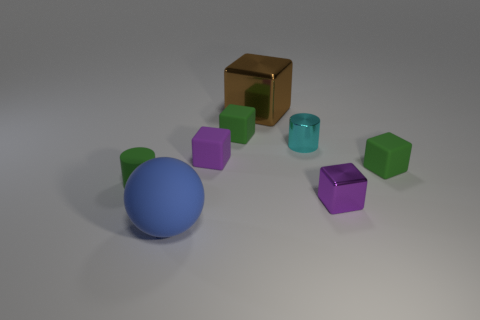Subtract 2 cubes. How many cubes are left? 3 Subtract all red blocks. Subtract all blue balls. How many blocks are left? 5 Add 1 large blue cubes. How many objects exist? 9 Subtract all spheres. How many objects are left? 7 Add 8 small green cylinders. How many small green cylinders are left? 9 Add 5 small purple rubber cylinders. How many small purple rubber cylinders exist? 5 Subtract 0 red cylinders. How many objects are left? 8 Subtract all brown things. Subtract all rubber balls. How many objects are left? 6 